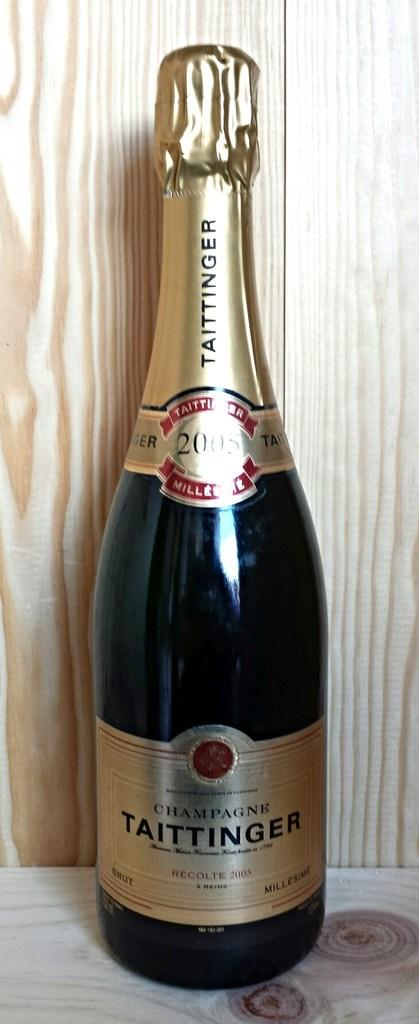<image>
Give a short and clear explanation of the subsequent image. A bottle of unopened champagne is on a wooden table. 